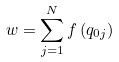<formula> <loc_0><loc_0><loc_500><loc_500>w = \sum _ { j = 1 } ^ { N } f \left ( q _ { 0 j } \right )</formula> 